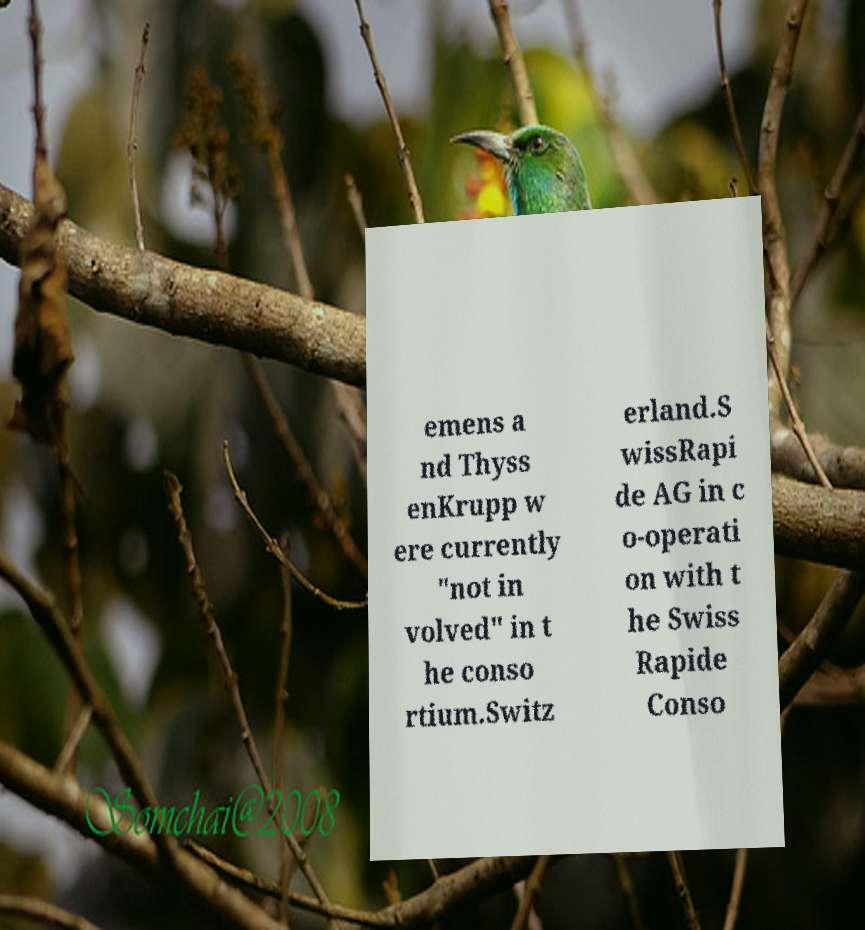I need the written content from this picture converted into text. Can you do that? emens a nd Thyss enKrupp w ere currently "not in volved" in t he conso rtium.Switz erland.S wissRapi de AG in c o-operati on with t he Swiss Rapide Conso 